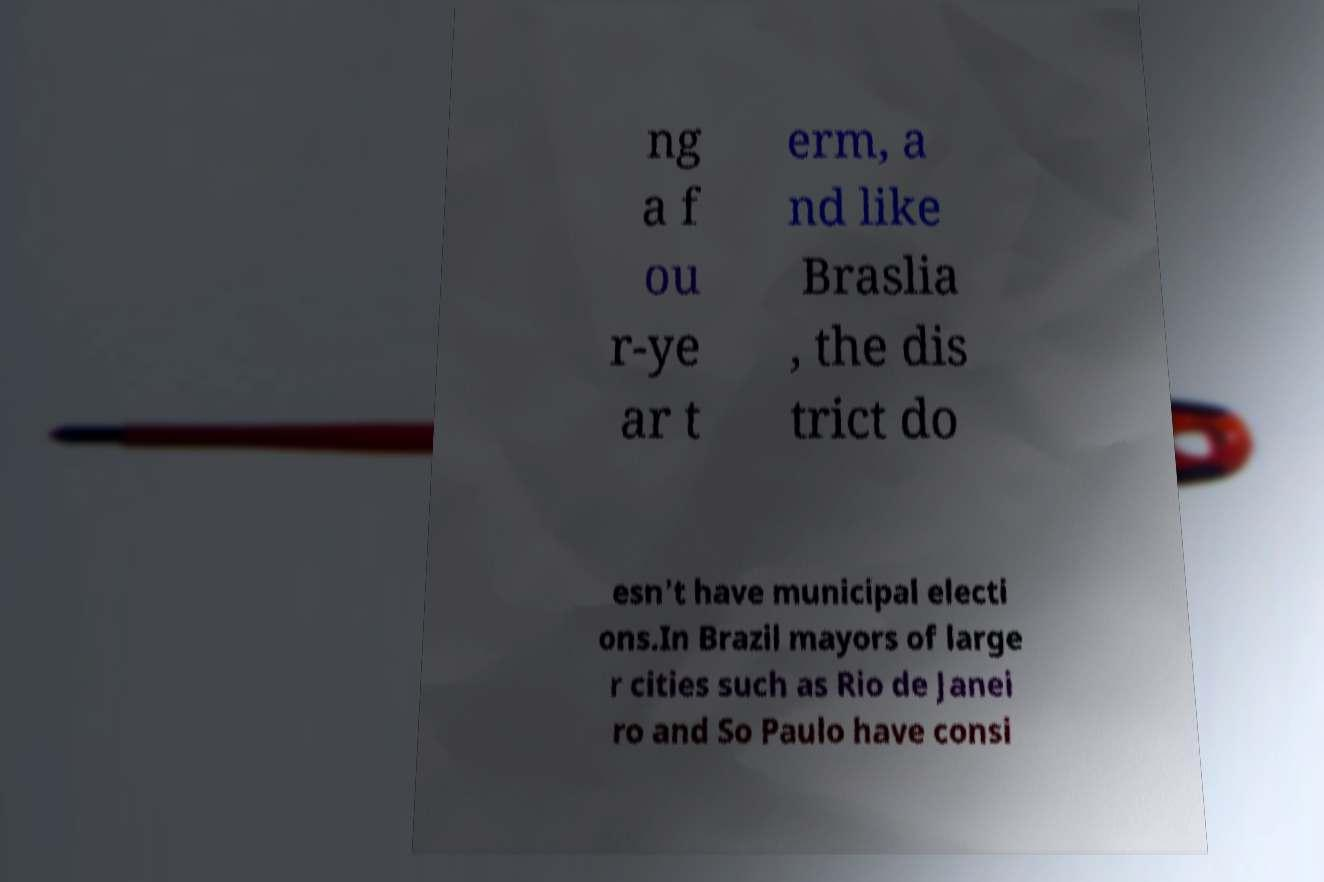What messages or text are displayed in this image? I need them in a readable, typed format. ng a f ou r-ye ar t erm, a nd like Braslia , the dis trict do esn't have municipal electi ons.In Brazil mayors of large r cities such as Rio de Janei ro and So Paulo have consi 